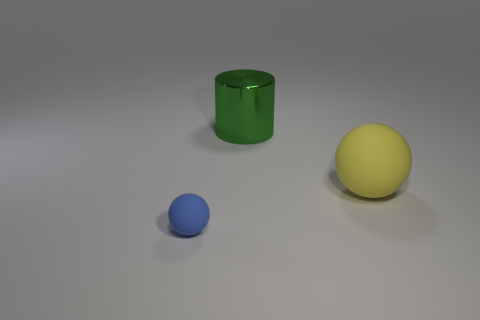Add 1 matte things. How many objects exist? 4 Subtract all cylinders. How many objects are left? 2 Add 3 yellow spheres. How many yellow spheres are left? 4 Add 3 large brown metallic cubes. How many large brown metallic cubes exist? 3 Subtract 0 brown spheres. How many objects are left? 3 Subtract all yellow objects. Subtract all green objects. How many objects are left? 1 